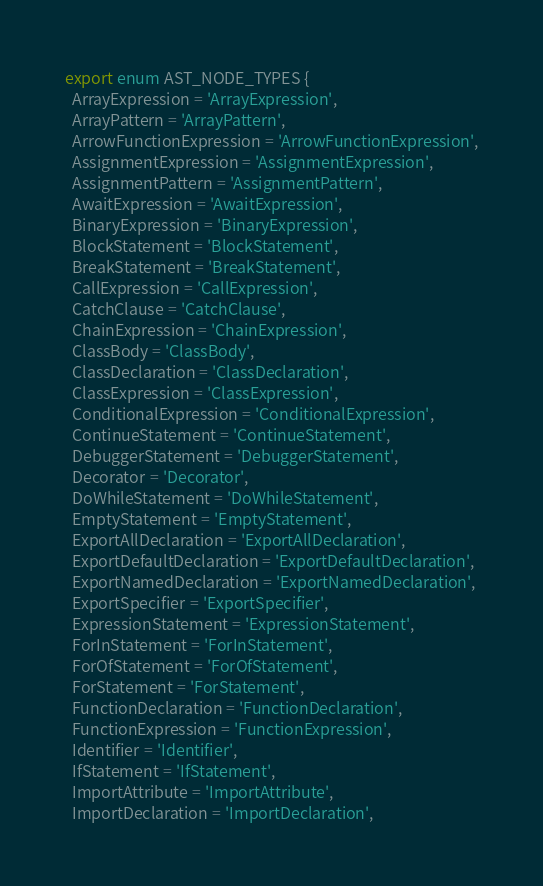Convert code to text. <code><loc_0><loc_0><loc_500><loc_500><_TypeScript_>export enum AST_NODE_TYPES {
  ArrayExpression = 'ArrayExpression',
  ArrayPattern = 'ArrayPattern',
  ArrowFunctionExpression = 'ArrowFunctionExpression',
  AssignmentExpression = 'AssignmentExpression',
  AssignmentPattern = 'AssignmentPattern',
  AwaitExpression = 'AwaitExpression',
  BinaryExpression = 'BinaryExpression',
  BlockStatement = 'BlockStatement',
  BreakStatement = 'BreakStatement',
  CallExpression = 'CallExpression',
  CatchClause = 'CatchClause',
  ChainExpression = 'ChainExpression',
  ClassBody = 'ClassBody',
  ClassDeclaration = 'ClassDeclaration',
  ClassExpression = 'ClassExpression',
  ConditionalExpression = 'ConditionalExpression',
  ContinueStatement = 'ContinueStatement',
  DebuggerStatement = 'DebuggerStatement',
  Decorator = 'Decorator',
  DoWhileStatement = 'DoWhileStatement',
  EmptyStatement = 'EmptyStatement',
  ExportAllDeclaration = 'ExportAllDeclaration',
  ExportDefaultDeclaration = 'ExportDefaultDeclaration',
  ExportNamedDeclaration = 'ExportNamedDeclaration',
  ExportSpecifier = 'ExportSpecifier',
  ExpressionStatement = 'ExpressionStatement',
  ForInStatement = 'ForInStatement',
  ForOfStatement = 'ForOfStatement',
  ForStatement = 'ForStatement',
  FunctionDeclaration = 'FunctionDeclaration',
  FunctionExpression = 'FunctionExpression',
  Identifier = 'Identifier',
  IfStatement = 'IfStatement',
  ImportAttribute = 'ImportAttribute',
  ImportDeclaration = 'ImportDeclaration',</code> 